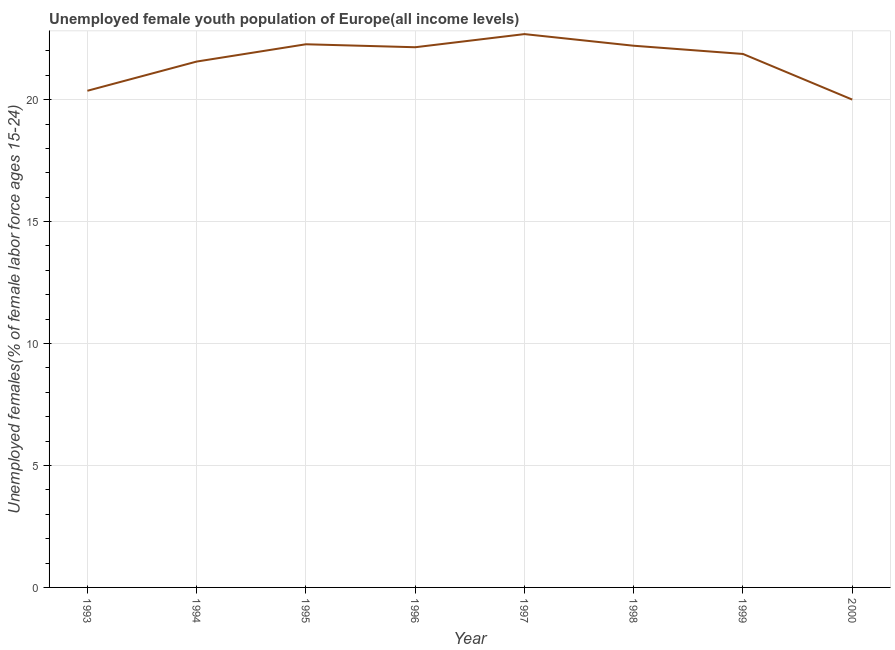What is the unemployed female youth in 1995?
Give a very brief answer. 22.27. Across all years, what is the maximum unemployed female youth?
Your answer should be very brief. 22.69. Across all years, what is the minimum unemployed female youth?
Make the answer very short. 20. What is the sum of the unemployed female youth?
Make the answer very short. 173.11. What is the difference between the unemployed female youth in 1999 and 2000?
Make the answer very short. 1.87. What is the average unemployed female youth per year?
Make the answer very short. 21.64. What is the median unemployed female youth?
Provide a short and direct response. 22.01. In how many years, is the unemployed female youth greater than 19 %?
Offer a very short reply. 8. What is the ratio of the unemployed female youth in 1996 to that in 1997?
Your answer should be compact. 0.98. Is the difference between the unemployed female youth in 1995 and 1999 greater than the difference between any two years?
Your answer should be very brief. No. What is the difference between the highest and the second highest unemployed female youth?
Provide a short and direct response. 0.42. Is the sum of the unemployed female youth in 1993 and 1994 greater than the maximum unemployed female youth across all years?
Keep it short and to the point. Yes. What is the difference between the highest and the lowest unemployed female youth?
Offer a very short reply. 2.69. In how many years, is the unemployed female youth greater than the average unemployed female youth taken over all years?
Offer a very short reply. 5. Does the unemployed female youth monotonically increase over the years?
Keep it short and to the point. No. How many lines are there?
Provide a short and direct response. 1. How many years are there in the graph?
Keep it short and to the point. 8. What is the difference between two consecutive major ticks on the Y-axis?
Make the answer very short. 5. Does the graph contain any zero values?
Provide a short and direct response. No. Does the graph contain grids?
Your response must be concise. Yes. What is the title of the graph?
Keep it short and to the point. Unemployed female youth population of Europe(all income levels). What is the label or title of the X-axis?
Keep it short and to the point. Year. What is the label or title of the Y-axis?
Your answer should be compact. Unemployed females(% of female labor force ages 15-24). What is the Unemployed females(% of female labor force ages 15-24) in 1993?
Ensure brevity in your answer.  20.36. What is the Unemployed females(% of female labor force ages 15-24) of 1994?
Offer a terse response. 21.56. What is the Unemployed females(% of female labor force ages 15-24) in 1995?
Your answer should be compact. 22.27. What is the Unemployed females(% of female labor force ages 15-24) of 1996?
Ensure brevity in your answer.  22.15. What is the Unemployed females(% of female labor force ages 15-24) in 1997?
Provide a succinct answer. 22.69. What is the Unemployed females(% of female labor force ages 15-24) of 1998?
Provide a short and direct response. 22.21. What is the Unemployed females(% of female labor force ages 15-24) in 1999?
Offer a terse response. 21.87. What is the Unemployed females(% of female labor force ages 15-24) in 2000?
Provide a succinct answer. 20. What is the difference between the Unemployed females(% of female labor force ages 15-24) in 1993 and 1994?
Ensure brevity in your answer.  -1.2. What is the difference between the Unemployed females(% of female labor force ages 15-24) in 1993 and 1995?
Give a very brief answer. -1.91. What is the difference between the Unemployed females(% of female labor force ages 15-24) in 1993 and 1996?
Ensure brevity in your answer.  -1.79. What is the difference between the Unemployed females(% of female labor force ages 15-24) in 1993 and 1997?
Provide a succinct answer. -2.32. What is the difference between the Unemployed females(% of female labor force ages 15-24) in 1993 and 1998?
Keep it short and to the point. -1.85. What is the difference between the Unemployed females(% of female labor force ages 15-24) in 1993 and 1999?
Keep it short and to the point. -1.51. What is the difference between the Unemployed females(% of female labor force ages 15-24) in 1993 and 2000?
Provide a short and direct response. 0.36. What is the difference between the Unemployed females(% of female labor force ages 15-24) in 1994 and 1995?
Provide a succinct answer. -0.71. What is the difference between the Unemployed females(% of female labor force ages 15-24) in 1994 and 1996?
Your answer should be very brief. -0.59. What is the difference between the Unemployed females(% of female labor force ages 15-24) in 1994 and 1997?
Offer a terse response. -1.13. What is the difference between the Unemployed females(% of female labor force ages 15-24) in 1994 and 1998?
Give a very brief answer. -0.65. What is the difference between the Unemployed females(% of female labor force ages 15-24) in 1994 and 1999?
Your answer should be very brief. -0.31. What is the difference between the Unemployed females(% of female labor force ages 15-24) in 1994 and 2000?
Ensure brevity in your answer.  1.56. What is the difference between the Unemployed females(% of female labor force ages 15-24) in 1995 and 1996?
Make the answer very short. 0.12. What is the difference between the Unemployed females(% of female labor force ages 15-24) in 1995 and 1997?
Offer a very short reply. -0.42. What is the difference between the Unemployed females(% of female labor force ages 15-24) in 1995 and 1998?
Offer a terse response. 0.06. What is the difference between the Unemployed females(% of female labor force ages 15-24) in 1995 and 1999?
Your answer should be very brief. 0.4. What is the difference between the Unemployed females(% of female labor force ages 15-24) in 1995 and 2000?
Ensure brevity in your answer.  2.27. What is the difference between the Unemployed females(% of female labor force ages 15-24) in 1996 and 1997?
Provide a short and direct response. -0.54. What is the difference between the Unemployed females(% of female labor force ages 15-24) in 1996 and 1998?
Give a very brief answer. -0.06. What is the difference between the Unemployed females(% of female labor force ages 15-24) in 1996 and 1999?
Your response must be concise. 0.28. What is the difference between the Unemployed females(% of female labor force ages 15-24) in 1996 and 2000?
Provide a succinct answer. 2.15. What is the difference between the Unemployed females(% of female labor force ages 15-24) in 1997 and 1998?
Keep it short and to the point. 0.48. What is the difference between the Unemployed females(% of female labor force ages 15-24) in 1997 and 1999?
Ensure brevity in your answer.  0.81. What is the difference between the Unemployed females(% of female labor force ages 15-24) in 1997 and 2000?
Keep it short and to the point. 2.69. What is the difference between the Unemployed females(% of female labor force ages 15-24) in 1998 and 1999?
Your answer should be compact. 0.34. What is the difference between the Unemployed females(% of female labor force ages 15-24) in 1998 and 2000?
Give a very brief answer. 2.21. What is the difference between the Unemployed females(% of female labor force ages 15-24) in 1999 and 2000?
Offer a terse response. 1.87. What is the ratio of the Unemployed females(% of female labor force ages 15-24) in 1993 to that in 1994?
Make the answer very short. 0.94. What is the ratio of the Unemployed females(% of female labor force ages 15-24) in 1993 to that in 1995?
Keep it short and to the point. 0.91. What is the ratio of the Unemployed females(% of female labor force ages 15-24) in 1993 to that in 1996?
Keep it short and to the point. 0.92. What is the ratio of the Unemployed females(% of female labor force ages 15-24) in 1993 to that in 1997?
Keep it short and to the point. 0.9. What is the ratio of the Unemployed females(% of female labor force ages 15-24) in 1993 to that in 1998?
Ensure brevity in your answer.  0.92. What is the ratio of the Unemployed females(% of female labor force ages 15-24) in 1993 to that in 1999?
Make the answer very short. 0.93. What is the ratio of the Unemployed females(% of female labor force ages 15-24) in 1994 to that in 1996?
Your response must be concise. 0.97. What is the ratio of the Unemployed females(% of female labor force ages 15-24) in 1994 to that in 1997?
Provide a short and direct response. 0.95. What is the ratio of the Unemployed females(% of female labor force ages 15-24) in 1994 to that in 2000?
Offer a very short reply. 1.08. What is the ratio of the Unemployed females(% of female labor force ages 15-24) in 1995 to that in 1996?
Provide a short and direct response. 1. What is the ratio of the Unemployed females(% of female labor force ages 15-24) in 1995 to that in 1997?
Your answer should be compact. 0.98. What is the ratio of the Unemployed females(% of female labor force ages 15-24) in 1995 to that in 1999?
Your answer should be compact. 1.02. What is the ratio of the Unemployed females(% of female labor force ages 15-24) in 1995 to that in 2000?
Offer a terse response. 1.11. What is the ratio of the Unemployed females(% of female labor force ages 15-24) in 1996 to that in 1997?
Your answer should be compact. 0.98. What is the ratio of the Unemployed females(% of female labor force ages 15-24) in 1996 to that in 1998?
Your response must be concise. 1. What is the ratio of the Unemployed females(% of female labor force ages 15-24) in 1996 to that in 2000?
Offer a very short reply. 1.11. What is the ratio of the Unemployed females(% of female labor force ages 15-24) in 1997 to that in 1999?
Provide a succinct answer. 1.04. What is the ratio of the Unemployed females(% of female labor force ages 15-24) in 1997 to that in 2000?
Make the answer very short. 1.13. What is the ratio of the Unemployed females(% of female labor force ages 15-24) in 1998 to that in 2000?
Provide a succinct answer. 1.11. What is the ratio of the Unemployed females(% of female labor force ages 15-24) in 1999 to that in 2000?
Offer a very short reply. 1.09. 